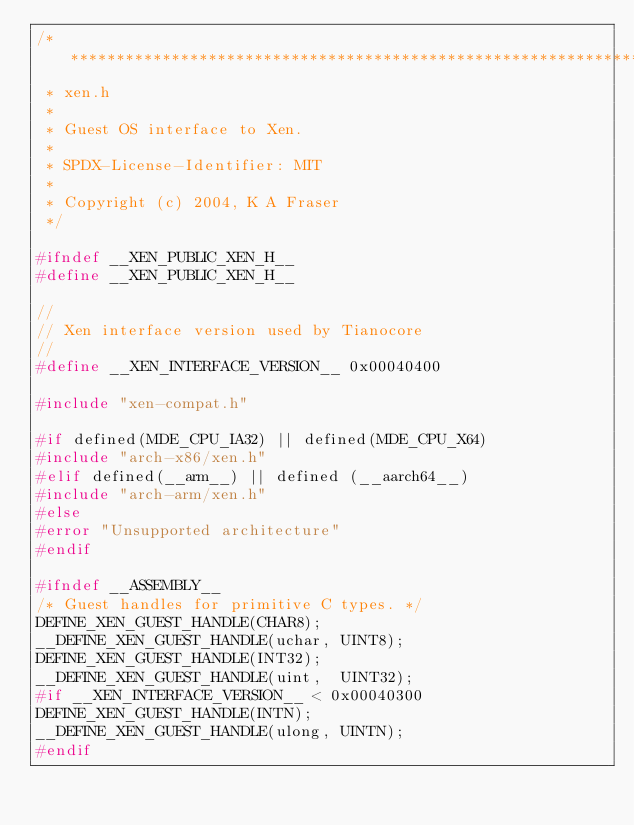<code> <loc_0><loc_0><loc_500><loc_500><_C_>/******************************************************************************
 * xen.h
 *
 * Guest OS interface to Xen.
 *
 * SPDX-License-Identifier: MIT
 *
 * Copyright (c) 2004, K A Fraser
 */

#ifndef __XEN_PUBLIC_XEN_H__
#define __XEN_PUBLIC_XEN_H__

//
// Xen interface version used by Tianocore
//
#define __XEN_INTERFACE_VERSION__ 0x00040400

#include "xen-compat.h"

#if defined(MDE_CPU_IA32) || defined(MDE_CPU_X64)
#include "arch-x86/xen.h"
#elif defined(__arm__) || defined (__aarch64__)
#include "arch-arm/xen.h"
#else
#error "Unsupported architecture"
#endif

#ifndef __ASSEMBLY__
/* Guest handles for primitive C types. */
DEFINE_XEN_GUEST_HANDLE(CHAR8);
__DEFINE_XEN_GUEST_HANDLE(uchar, UINT8);
DEFINE_XEN_GUEST_HANDLE(INT32);
__DEFINE_XEN_GUEST_HANDLE(uint,  UINT32);
#if __XEN_INTERFACE_VERSION__ < 0x00040300
DEFINE_XEN_GUEST_HANDLE(INTN);
__DEFINE_XEN_GUEST_HANDLE(ulong, UINTN);
#endif</code> 